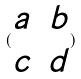<formula> <loc_0><loc_0><loc_500><loc_500>( \begin{matrix} a & b \\ c & d \end{matrix} )</formula> 